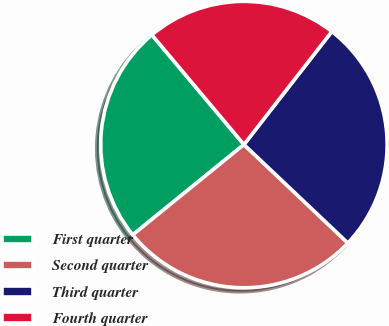Convert chart. <chart><loc_0><loc_0><loc_500><loc_500><pie_chart><fcel>First quarter<fcel>Second quarter<fcel>Third quarter<fcel>Fourth quarter<nl><fcel>24.74%<fcel>27.07%<fcel>26.55%<fcel>21.63%<nl></chart> 